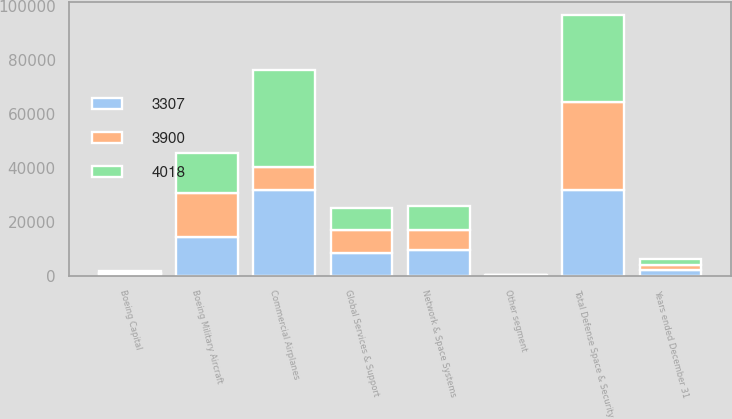<chart> <loc_0><loc_0><loc_500><loc_500><stacked_bar_chart><ecel><fcel>Years ended December 31<fcel>Commercial Airplanes<fcel>Boeing Military Aircraft<fcel>Network & Space Systems<fcel>Global Services & Support<fcel>Total Defense Space & Security<fcel>Boeing Capital<fcel>Other segment<nl><fcel>3900<fcel>2012<fcel>8375<fcel>16384<fcel>7584<fcel>8639<fcel>32607<fcel>441<fcel>133<nl><fcel>4018<fcel>2011<fcel>36171<fcel>14947<fcel>8654<fcel>8375<fcel>31976<fcel>520<fcel>150<nl><fcel>3307<fcel>2010<fcel>31834<fcel>14238<fcel>9449<fcel>8256<fcel>31943<fcel>639<fcel>138<nl></chart> 